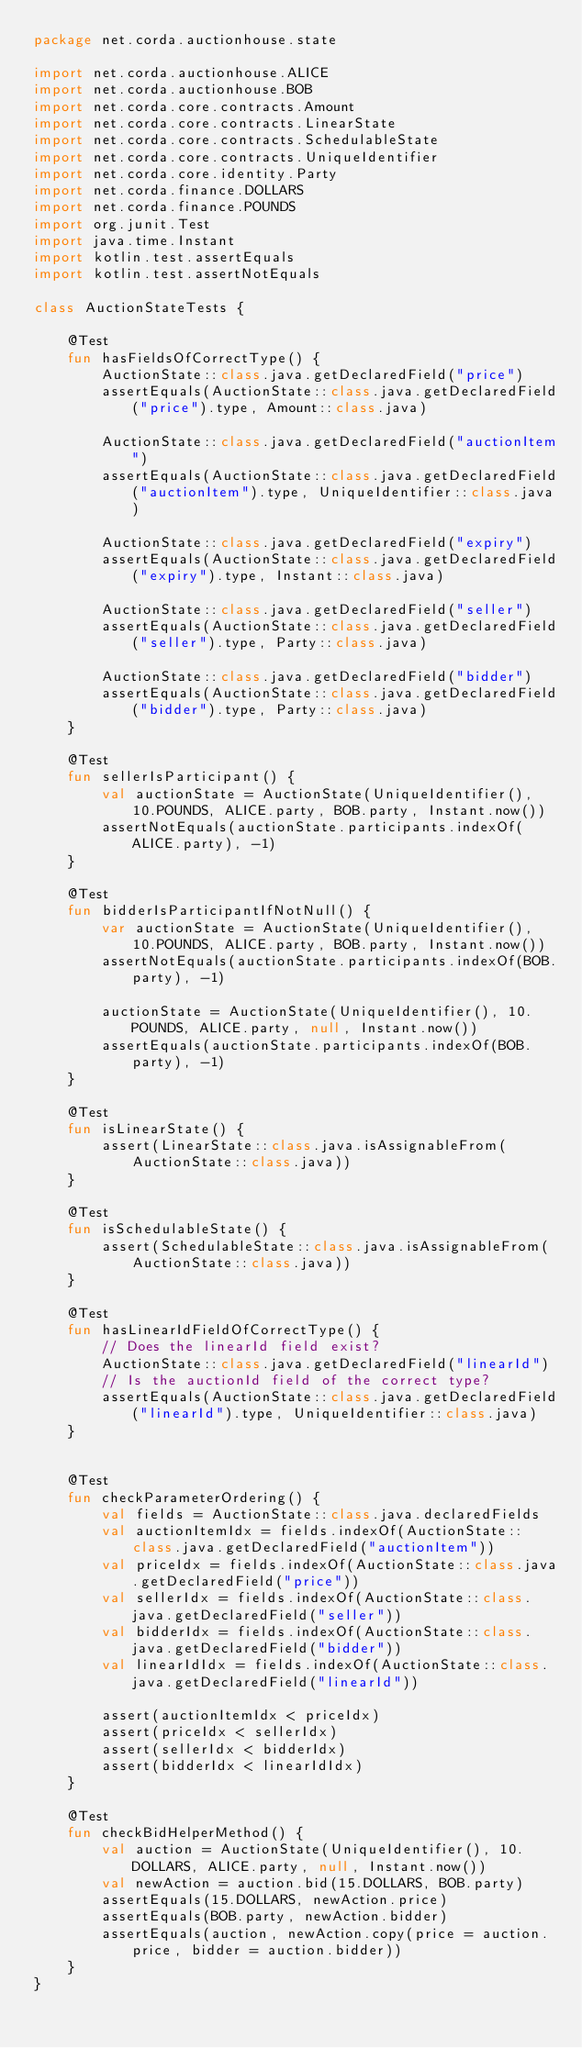<code> <loc_0><loc_0><loc_500><loc_500><_Kotlin_>package net.corda.auctionhouse.state

import net.corda.auctionhouse.ALICE
import net.corda.auctionhouse.BOB
import net.corda.core.contracts.Amount
import net.corda.core.contracts.LinearState
import net.corda.core.contracts.SchedulableState
import net.corda.core.contracts.UniqueIdentifier
import net.corda.core.identity.Party
import net.corda.finance.DOLLARS
import net.corda.finance.POUNDS
import org.junit.Test
import java.time.Instant
import kotlin.test.assertEquals
import kotlin.test.assertNotEquals

class AuctionStateTests {

    @Test
    fun hasFieldsOfCorrectType() {
        AuctionState::class.java.getDeclaredField("price")
        assertEquals(AuctionState::class.java.getDeclaredField("price").type, Amount::class.java)

        AuctionState::class.java.getDeclaredField("auctionItem")
        assertEquals(AuctionState::class.java.getDeclaredField("auctionItem").type, UniqueIdentifier::class.java)

        AuctionState::class.java.getDeclaredField("expiry")
        assertEquals(AuctionState::class.java.getDeclaredField("expiry").type, Instant::class.java)

        AuctionState::class.java.getDeclaredField("seller")
        assertEquals(AuctionState::class.java.getDeclaredField("seller").type, Party::class.java)

        AuctionState::class.java.getDeclaredField("bidder")
        assertEquals(AuctionState::class.java.getDeclaredField("bidder").type, Party::class.java)
    }

    @Test
    fun sellerIsParticipant() {
        val auctionState = AuctionState(UniqueIdentifier(), 10.POUNDS, ALICE.party, BOB.party, Instant.now())
        assertNotEquals(auctionState.participants.indexOf(ALICE.party), -1)
    }

    @Test
    fun bidderIsParticipantIfNotNull() {
        var auctionState = AuctionState(UniqueIdentifier(), 10.POUNDS, ALICE.party, BOB.party, Instant.now())
        assertNotEquals(auctionState.participants.indexOf(BOB.party), -1)

        auctionState = AuctionState(UniqueIdentifier(), 10.POUNDS, ALICE.party, null, Instant.now())
        assertEquals(auctionState.participants.indexOf(BOB.party), -1)
    }

    @Test
    fun isLinearState() {
        assert(LinearState::class.java.isAssignableFrom(AuctionState::class.java))
    }

    @Test
    fun isSchedulableState() {
        assert(SchedulableState::class.java.isAssignableFrom(AuctionState::class.java))
    }

    @Test
    fun hasLinearIdFieldOfCorrectType() {
        // Does the linearId field exist?
        AuctionState::class.java.getDeclaredField("linearId")
        // Is the auctionId field of the correct type?
        assertEquals(AuctionState::class.java.getDeclaredField("linearId").type, UniqueIdentifier::class.java)
    }


    @Test
    fun checkParameterOrdering() {
        val fields = AuctionState::class.java.declaredFields
        val auctionItemIdx = fields.indexOf(AuctionState::class.java.getDeclaredField("auctionItem"))
        val priceIdx = fields.indexOf(AuctionState::class.java.getDeclaredField("price"))
        val sellerIdx = fields.indexOf(AuctionState::class.java.getDeclaredField("seller"))
        val bidderIdx = fields.indexOf(AuctionState::class.java.getDeclaredField("bidder"))
        val linearIdIdx = fields.indexOf(AuctionState::class.java.getDeclaredField("linearId"))

        assert(auctionItemIdx < priceIdx)
        assert(priceIdx < sellerIdx)
        assert(sellerIdx < bidderIdx)
        assert(bidderIdx < linearIdIdx)
    }

    @Test
    fun checkBidHelperMethod() {
        val auction = AuctionState(UniqueIdentifier(), 10.DOLLARS, ALICE.party, null, Instant.now())
        val newAction = auction.bid(15.DOLLARS, BOB.party)
        assertEquals(15.DOLLARS, newAction.price)
        assertEquals(BOB.party, newAction.bidder)
        assertEquals(auction, newAction.copy(price = auction.price, bidder = auction.bidder))
    }
}
</code> 